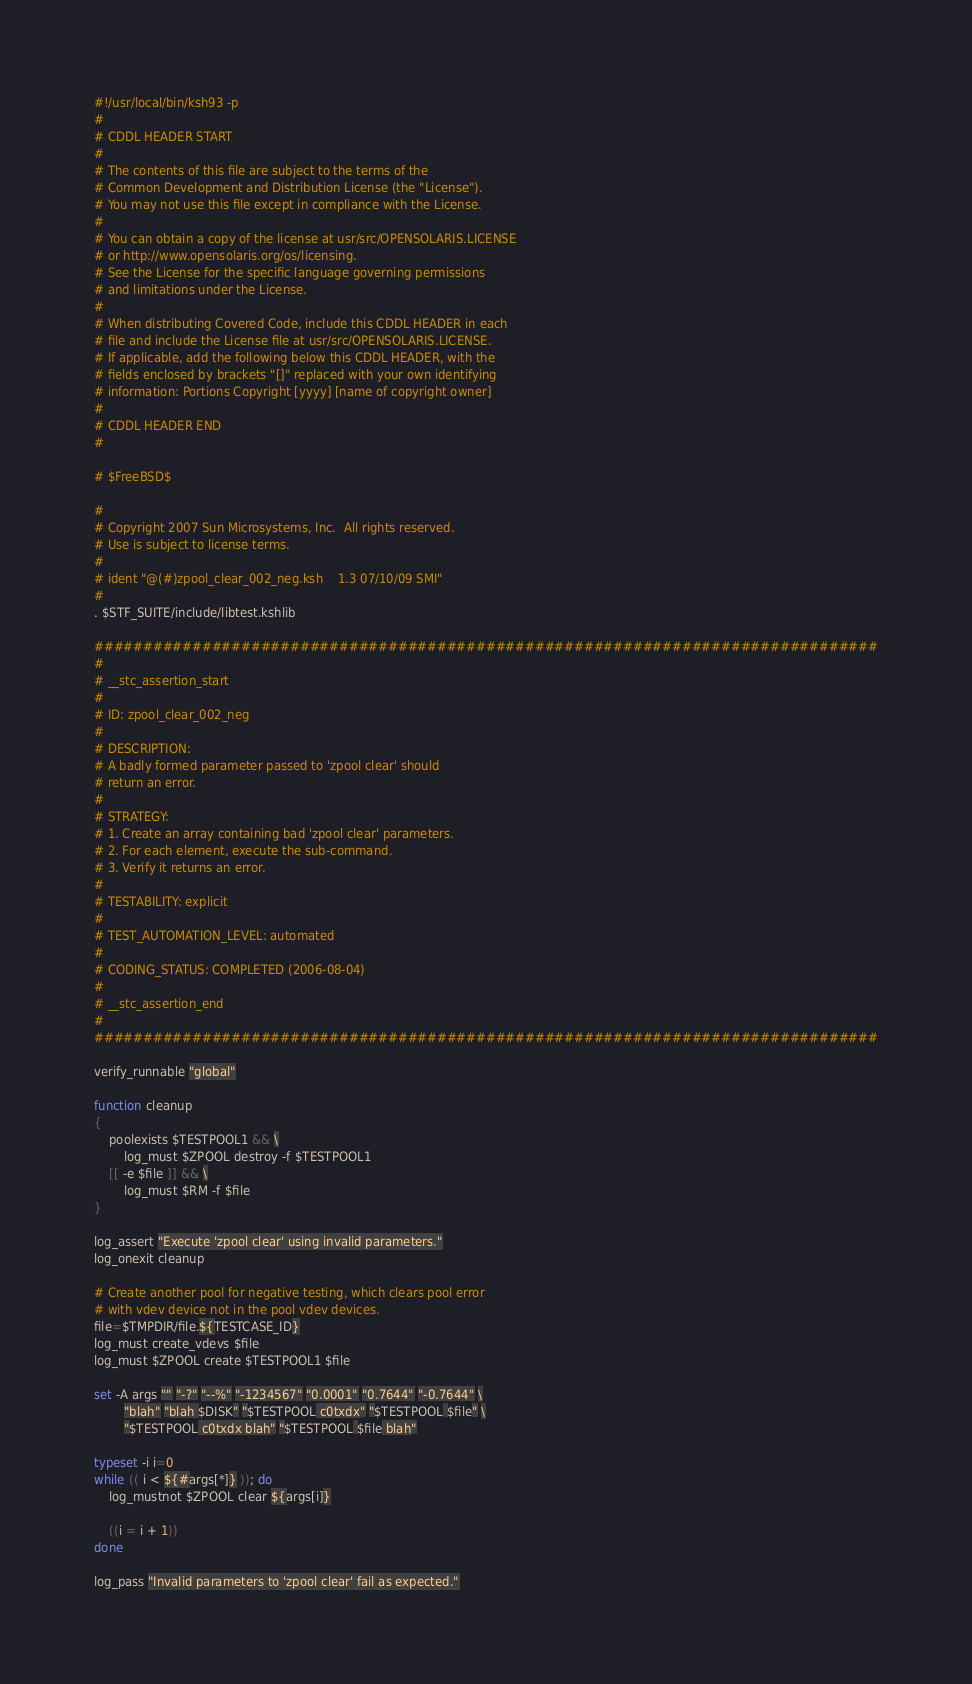<code> <loc_0><loc_0><loc_500><loc_500><_Bash_>#!/usr/local/bin/ksh93 -p
#
# CDDL HEADER START
#
# The contents of this file are subject to the terms of the
# Common Development and Distribution License (the "License").
# You may not use this file except in compliance with the License.
#
# You can obtain a copy of the license at usr/src/OPENSOLARIS.LICENSE
# or http://www.opensolaris.org/os/licensing.
# See the License for the specific language governing permissions
# and limitations under the License.
#
# When distributing Covered Code, include this CDDL HEADER in each
# file and include the License file at usr/src/OPENSOLARIS.LICENSE.
# If applicable, add the following below this CDDL HEADER, with the
# fields enclosed by brackets "[]" replaced with your own identifying
# information: Portions Copyright [yyyy] [name of copyright owner]
#
# CDDL HEADER END
#

# $FreeBSD$

#
# Copyright 2007 Sun Microsystems, Inc.  All rights reserved.
# Use is subject to license terms.
#
# ident	"@(#)zpool_clear_002_neg.ksh	1.3	07/10/09 SMI"
#
. $STF_SUITE/include/libtest.kshlib

################################################################################
#
# __stc_assertion_start
#
# ID: zpool_clear_002_neg
#
# DESCRIPTION:
# A badly formed parameter passed to 'zpool clear' should
# return an error.
#
# STRATEGY:
# 1. Create an array containing bad 'zpool clear' parameters.
# 2. For each element, execute the sub-command.
# 3. Verify it returns an error.
#
# TESTABILITY: explicit
#
# TEST_AUTOMATION_LEVEL: automated
#
# CODING_STATUS: COMPLETED (2006-08-04)
#
# __stc_assertion_end
#
################################################################################

verify_runnable "global"

function cleanup
{
	poolexists $TESTPOOL1 && \
		log_must $ZPOOL destroy -f $TESTPOOL1
	[[ -e $file ]] && \
		log_must $RM -f $file
}

log_assert "Execute 'zpool clear' using invalid parameters."
log_onexit cleanup

# Create another pool for negative testing, which clears pool error 
# with vdev device not in the pool vdev devices.
file=$TMPDIR/file.${TESTCASE_ID}
log_must create_vdevs $file
log_must $ZPOOL create $TESTPOOL1 $file

set -A args "" "-?" "--%" "-1234567" "0.0001" "0.7644" "-0.7644" \
		"blah" "blah $DISK" "$TESTPOOL c0txdx" "$TESTPOOL $file" \
		"$TESTPOOL c0txdx blah" "$TESTPOOL $file blah"

typeset -i i=0
while (( i < ${#args[*]} )); do
	log_mustnot $ZPOOL clear ${args[i]}

	((i = i + 1))
done

log_pass "Invalid parameters to 'zpool clear' fail as expected."
</code> 